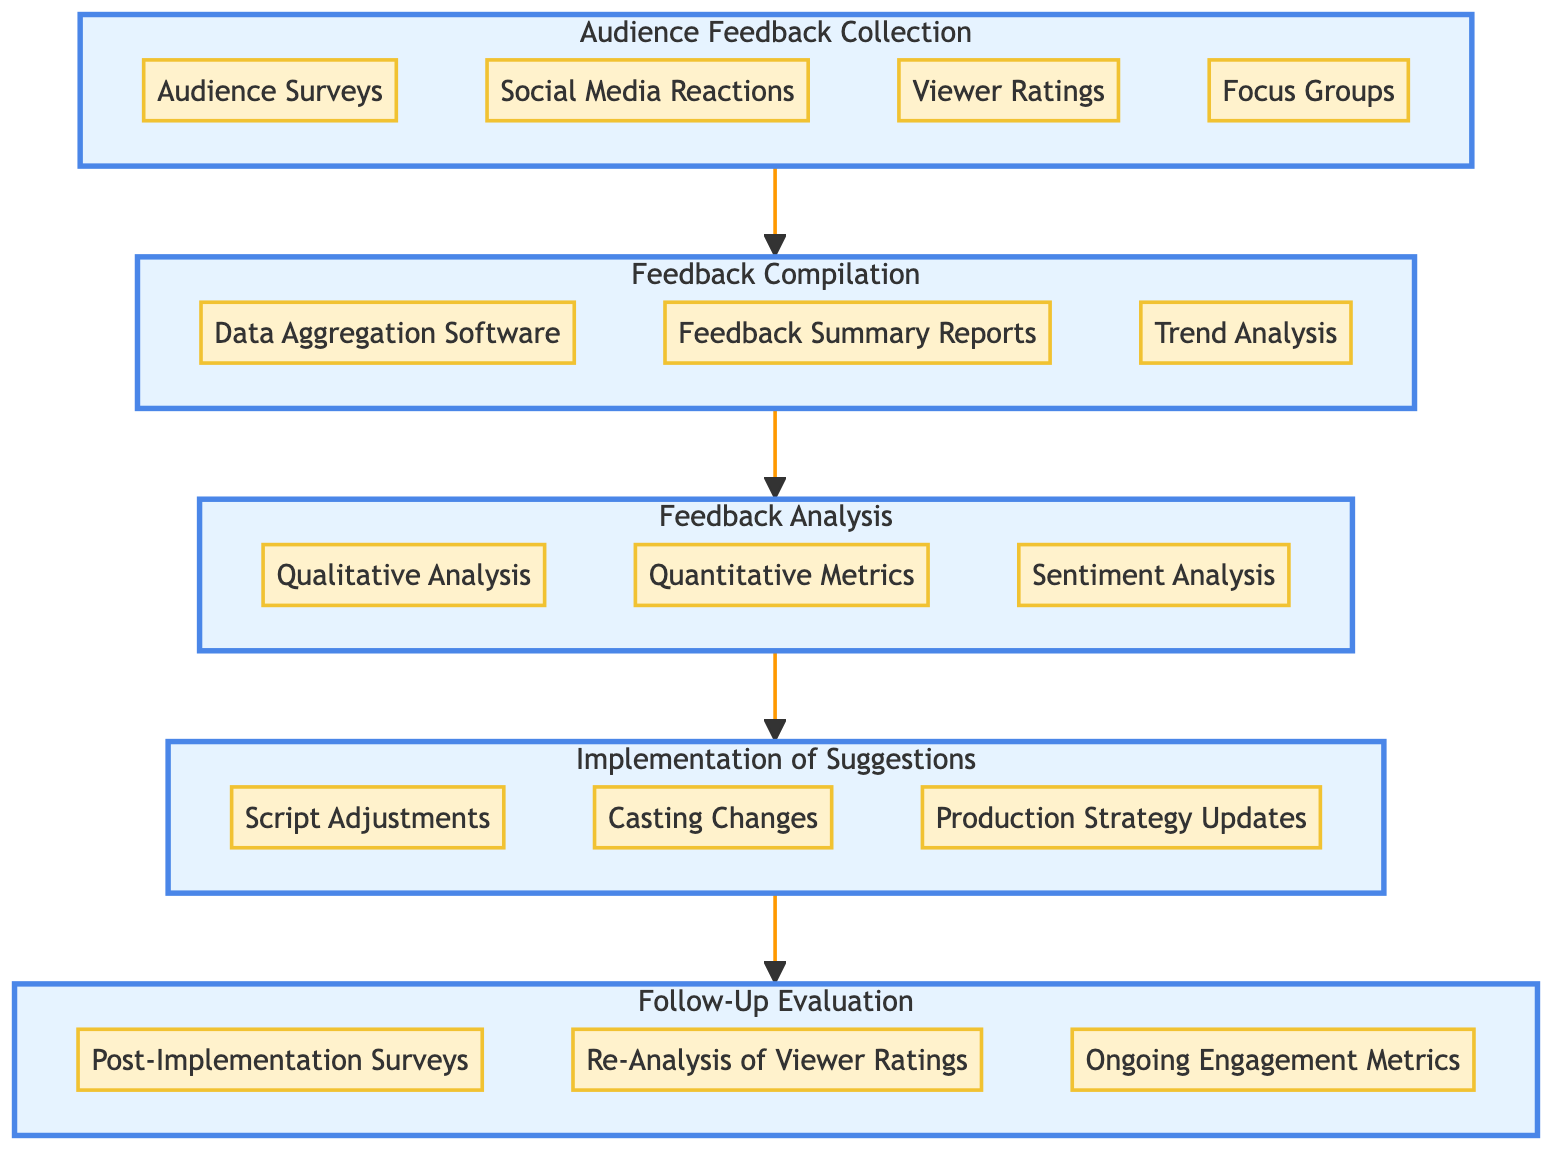What stage follows "Audience Feedback Collection"? Looking at the flow of the diagram, after the "Audience Feedback Collection" stage, the next stage connected through an arrow is "Feedback Compilation."
Answer: Feedback Compilation How many entities are listed under "Feedback Analysis"? In the "Feedback Analysis" section, there are three entities mentioned: "Qualitative Analysis," "Quantitative Metrics," and "Sentiment Analysis." Hence, the count is three.
Answer: Three What entities are included in the "Implementation of Suggestions" stage? The "Implementation of Suggestions" stage consists of the following entities: "Script Adjustments," "Casting Changes," and "Production Strategy Updates." These three entities define this stage.
Answer: Script Adjustments, Casting Changes, Production Strategy Updates Which stage is directly connected to "Follow-Up Evaluation"? The "Follow-Up Evaluation" stage is the final stage in the flow and is directly preceded by the "Implementation of Suggestions" stage, which points into it.
Answer: Implementation of Suggestions What is the first step in the audience feedback flow? The first step in the audience feedback flow is represented by the "Audience Feedback Collection" stage, which initiates the overall process.
Answer: Audience Feedback Collection How many stages are in the entire feedback flow? The diagram illustrates five distinct stages that make up the audience feedback flow: "Audience Feedback Collection," "Feedback Compilation," "Feedback Analysis," "Implementation of Suggestions," and "Follow-Up Evaluation." Thus, the total is five.
Answer: Five Which two entities form the link between "Feedback Compilation" and "Feedback Analysis"? The two entities that create a connection between "Feedback Compilation" and "Feedback Analysis" are likely "Data Aggregation Software" and "Feedback Summary Reports," which contribute to analyzing the compiled feedback.
Answer: Data Aggregation Software, Feedback Summary Reports What is the primary purpose of the "Follow-Up Evaluation" stage? The "Follow-Up Evaluation" stage serves the purpose of assessing the effectiveness of the implemented suggestions by collecting further feedback and data insights after changes have been made.
Answer: Assessing effectiveness Which subgraph contains the entity "Social Media Reactions"? The entity "Social Media Reactions" is included in the subgraph for the "Audience Feedback Collection" stage, as it is one of the methods used to gather initial audience feedback.
Answer: Audience Feedback Collection 